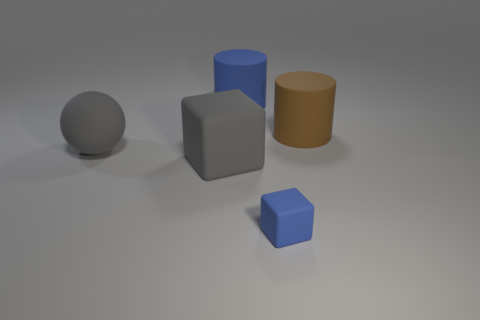What number of small gray rubber cylinders are there?
Your answer should be compact. 0. There is a blue object right of the blue cylinder; is it the same shape as the large brown matte object?
Offer a very short reply. No. Are there any large blue objects made of the same material as the large gray block?
Make the answer very short. Yes. There is a small blue thing; is it the same shape as the gray rubber thing that is in front of the gray matte sphere?
Make the answer very short. Yes. What number of matte things are both behind the gray cube and to the right of the large blue matte cylinder?
Your response must be concise. 1. Does the large ball have the same material as the block that is on the right side of the large blue matte thing?
Provide a short and direct response. Yes. Are there the same number of large balls that are to the right of the large brown thing and tiny gray metal blocks?
Offer a very short reply. Yes. The small rubber cube that is in front of the large ball is what color?
Your answer should be compact. Blue. How many other things are the same color as the ball?
Offer a terse response. 1. Is there any other thing that has the same size as the blue rubber block?
Your answer should be compact. No. 